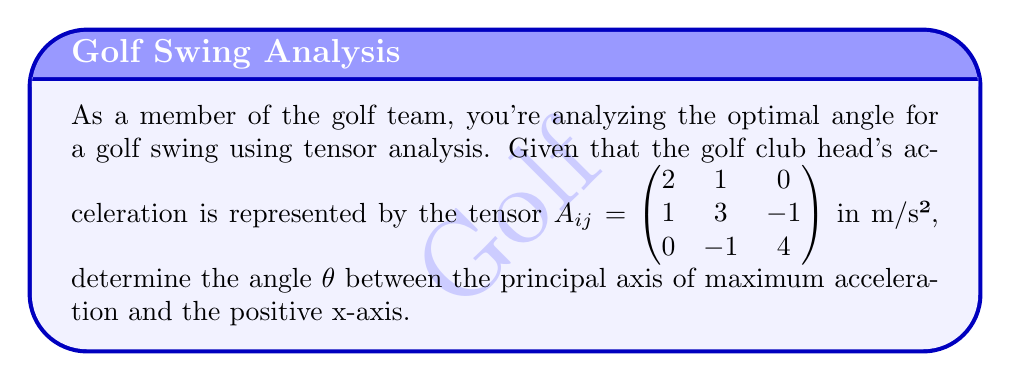Show me your answer to this math problem. To find the optimal angle for the golf swing, we need to determine the principal axes of the acceleration tensor. This involves the following steps:

1) First, we need to find the eigenvalues of the tensor $A_{ij}$. The characteristic equation is:

   $$\det(A_{ij} - \lambda I) = \begin{vmatrix} 
   2-\lambda & 1 & 0 \\
   1 & 3-\lambda & -1 \\
   0 & -1 & 4-\lambda
   \end{vmatrix} = 0$$

2) Expanding this determinant:

   $$(2-\lambda)(3-\lambda)(4-\lambda) + 1(-1) + 0 - 0 - (2-\lambda)(-1)(-1) = 0$$
   $$-\lambda^3 + 9\lambda^2 - 26\lambda + 24 + 1 - 2 + \lambda = 0$$
   $$-\lambda^3 + 9\lambda^2 - 25\lambda + 23 = 0$$

3) Solving this equation (you can use a calculator or computer for this step), we get:
   $\lambda_1 \approx 4.83$, $\lambda_2 \approx 2.94$, $\lambda_3 \approx 1.23$

4) The largest eigenvalue $\lambda_1 \approx 4.83$ corresponds to the direction of maximum acceleration.

5) To find the direction of this principal axis, we need to find the eigenvector $\vec{v}$ corresponding to $\lambda_1$:

   $$(A_{ij} - \lambda_1 I)\vec{v} = 0$$

   $$\begin{pmatrix} 
   -2.83 & 1 & 0 \\
   1 & -1.83 & -1 \\
   0 & -1 & -0.83
   \end{pmatrix}\begin{pmatrix} 
   v_1 \\ v_2 \\ v_3
   \end{pmatrix} = \begin{pmatrix} 
   0 \\ 0 \\ 0
   \end{pmatrix}$$

6) Solving this system (again, you can use a calculator), we get the eigenvector:
   $\vec{v} \approx (0.7071, 0.7071, 0)$

7) The angle θ between this vector and the positive x-axis is given by:

   $$\theta = \arctan(\frac{v_2}{v_1}) = \arctan(\frac{0.7071}{0.7071}) = \arctan(1) = 45°$$

Therefore, the optimal angle for the golf swing, which aligns with the direction of maximum acceleration, is approximately 45° from the positive x-axis.
Answer: 45° 